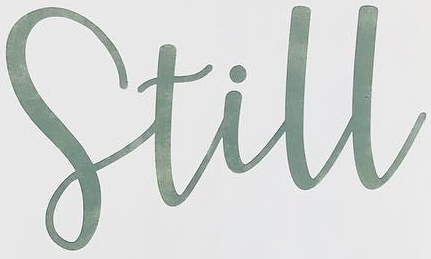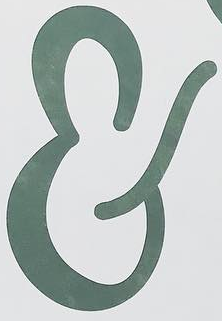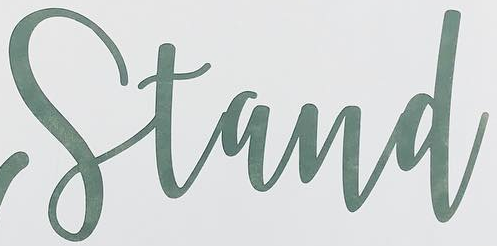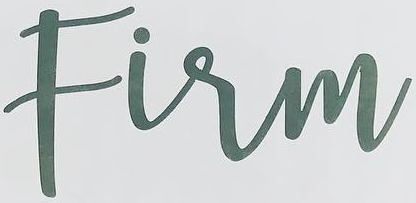Read the text content from these images in order, separated by a semicolon. Still; &; Stand; Firm 